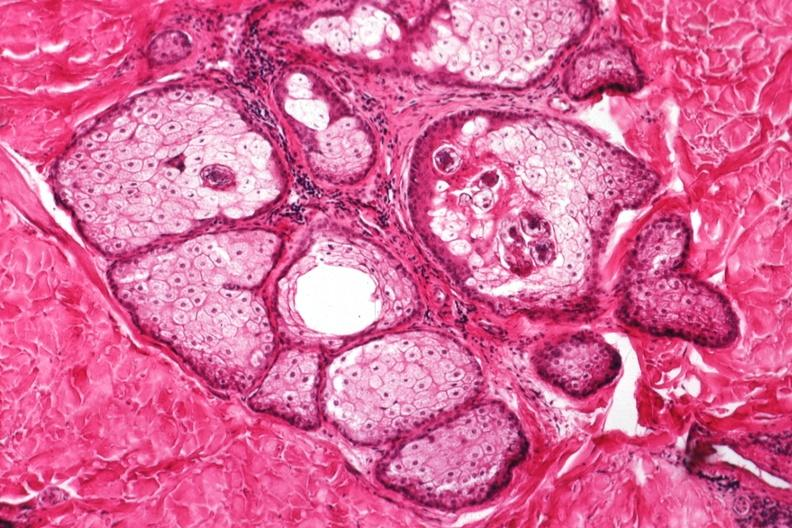s fibrinous peritonitis present?
Answer the question using a single word or phrase. No 